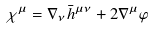<formula> <loc_0><loc_0><loc_500><loc_500>\chi ^ { \mu } = \nabla _ { \nu } \bar { h } ^ { \mu \nu } + 2 \nabla ^ { \mu } \varphi</formula> 